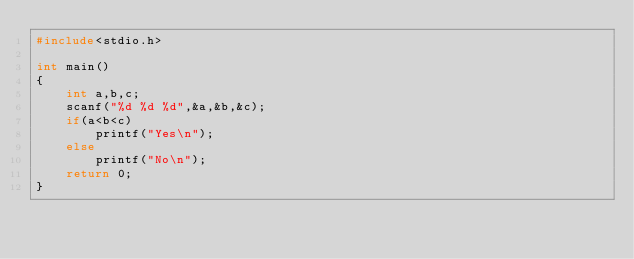<code> <loc_0><loc_0><loc_500><loc_500><_C_>#include<stdio.h>

int main()
{
    int a,b,c;
    scanf("%d %d %d",&a,&b,&c);
    if(a<b<c)
        printf("Yes\n");
    else
        printf("No\n");
    return 0;
}
</code> 